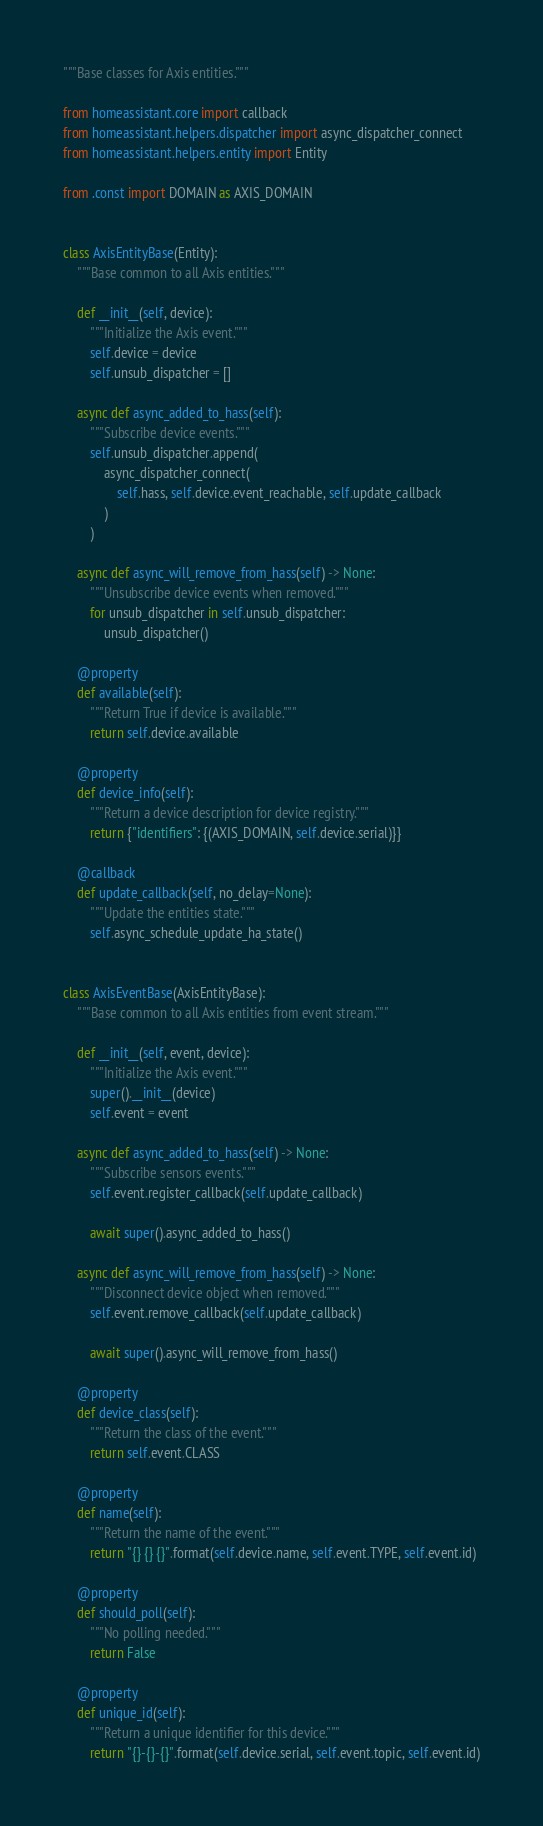<code> <loc_0><loc_0><loc_500><loc_500><_Python_>"""Base classes for Axis entities."""

from homeassistant.core import callback
from homeassistant.helpers.dispatcher import async_dispatcher_connect
from homeassistant.helpers.entity import Entity

from .const import DOMAIN as AXIS_DOMAIN


class AxisEntityBase(Entity):
    """Base common to all Axis entities."""

    def __init__(self, device):
        """Initialize the Axis event."""
        self.device = device
        self.unsub_dispatcher = []

    async def async_added_to_hass(self):
        """Subscribe device events."""
        self.unsub_dispatcher.append(
            async_dispatcher_connect(
                self.hass, self.device.event_reachable, self.update_callback
            )
        )

    async def async_will_remove_from_hass(self) -> None:
        """Unsubscribe device events when removed."""
        for unsub_dispatcher in self.unsub_dispatcher:
            unsub_dispatcher()

    @property
    def available(self):
        """Return True if device is available."""
        return self.device.available

    @property
    def device_info(self):
        """Return a device description for device registry."""
        return {"identifiers": {(AXIS_DOMAIN, self.device.serial)}}

    @callback
    def update_callback(self, no_delay=None):
        """Update the entities state."""
        self.async_schedule_update_ha_state()


class AxisEventBase(AxisEntityBase):
    """Base common to all Axis entities from event stream."""

    def __init__(self, event, device):
        """Initialize the Axis event."""
        super().__init__(device)
        self.event = event

    async def async_added_to_hass(self) -> None:
        """Subscribe sensors events."""
        self.event.register_callback(self.update_callback)

        await super().async_added_to_hass()

    async def async_will_remove_from_hass(self) -> None:
        """Disconnect device object when removed."""
        self.event.remove_callback(self.update_callback)

        await super().async_will_remove_from_hass()

    @property
    def device_class(self):
        """Return the class of the event."""
        return self.event.CLASS

    @property
    def name(self):
        """Return the name of the event."""
        return "{} {} {}".format(self.device.name, self.event.TYPE, self.event.id)

    @property
    def should_poll(self):
        """No polling needed."""
        return False

    @property
    def unique_id(self):
        """Return a unique identifier for this device."""
        return "{}-{}-{}".format(self.device.serial, self.event.topic, self.event.id)
</code> 